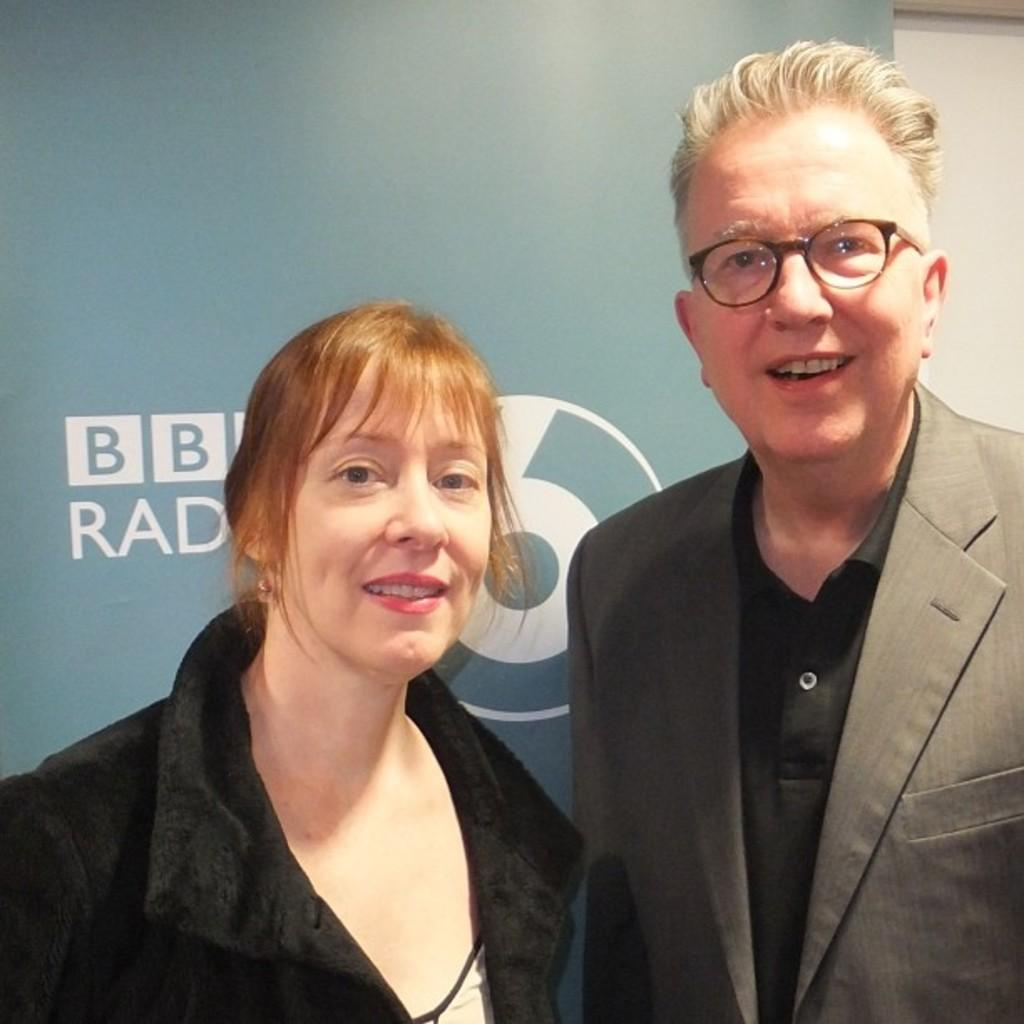Who is present in the image? There is a man and a woman in the image. What are the facial expressions of the people in the image? Both the man and the woman are smiling in the image. What can be seen in the background of the image? There is a board in the background of the image. What type of stick can be seen in the hands of the man in the image? There is no stick present in the hands of the man or in the image. Can you tell me if there is a zoo in the background of the image? There is no mention of a zoo or any related elements in the image. 